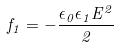Convert formula to latex. <formula><loc_0><loc_0><loc_500><loc_500>f _ { 1 } = - \frac { \epsilon _ { 0 } \epsilon _ { 1 } E ^ { 2 } } { 2 }</formula> 